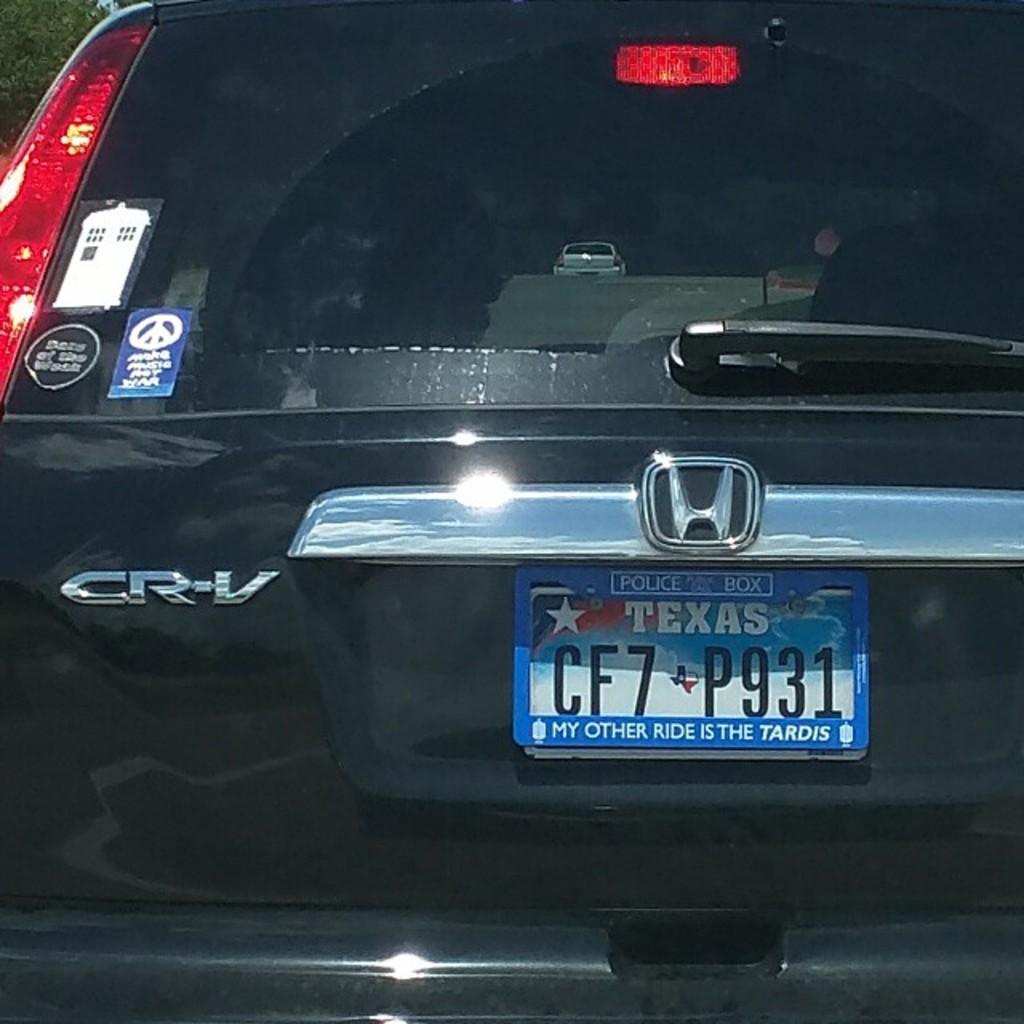<image>
Describe the image concisely. A black Honda CR-V with a license plate from Texas. 